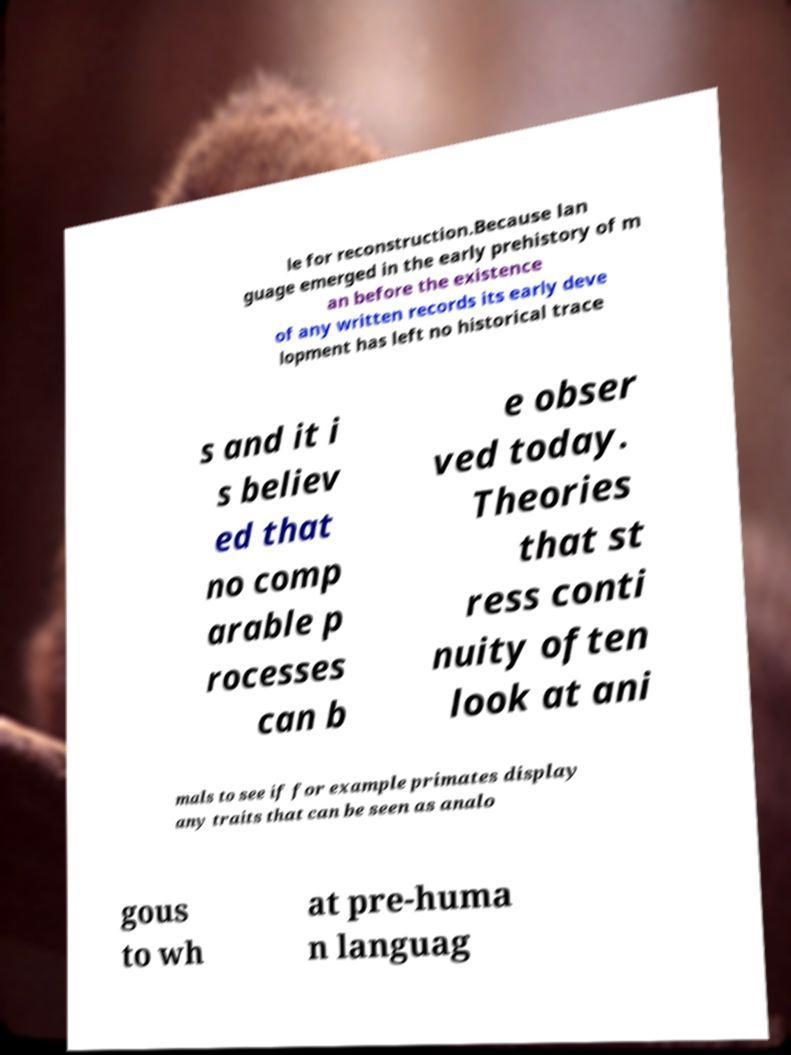Can you read and provide the text displayed in the image?This photo seems to have some interesting text. Can you extract and type it out for me? le for reconstruction.Because lan guage emerged in the early prehistory of m an before the existence of any written records its early deve lopment has left no historical trace s and it i s believ ed that no comp arable p rocesses can b e obser ved today. Theories that st ress conti nuity often look at ani mals to see if for example primates display any traits that can be seen as analo gous to wh at pre-huma n languag 